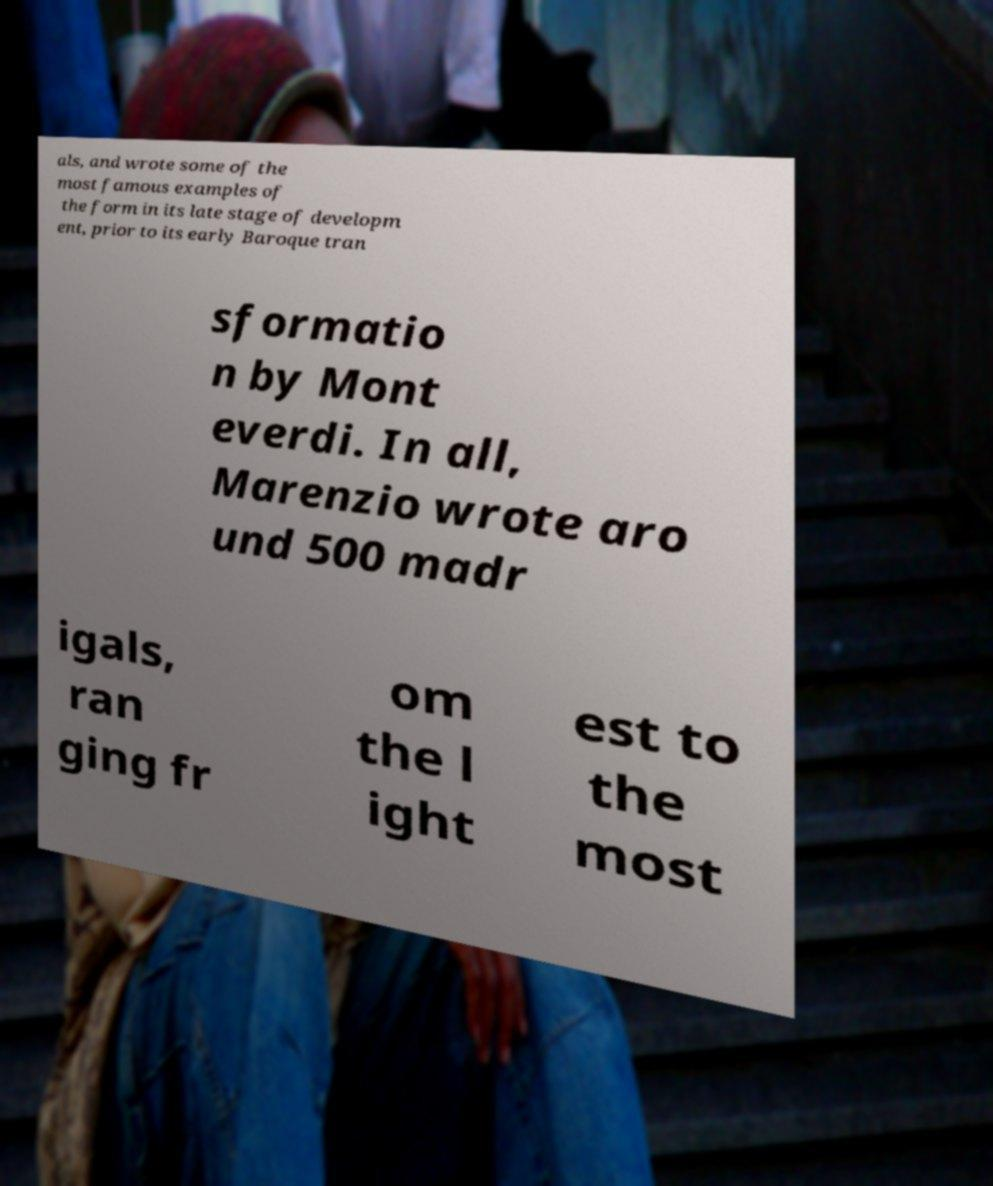Please read and relay the text visible in this image. What does it say? als, and wrote some of the most famous examples of the form in its late stage of developm ent, prior to its early Baroque tran sformatio n by Mont everdi. In all, Marenzio wrote aro und 500 madr igals, ran ging fr om the l ight est to the most 